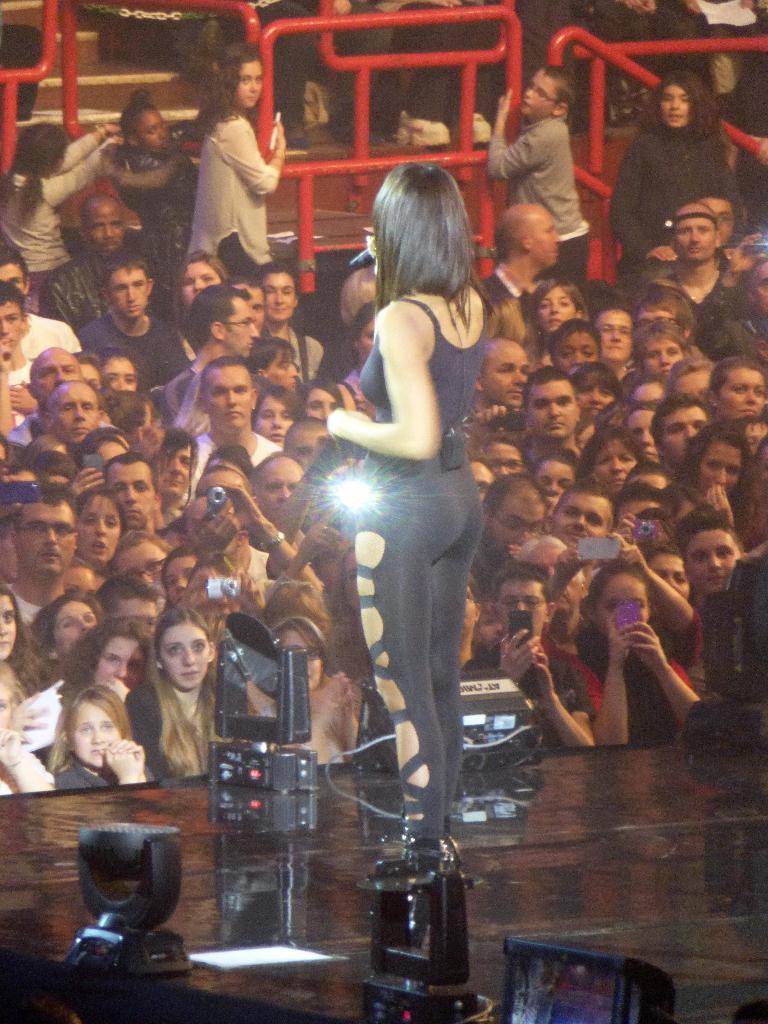Please provide a concise description of this image. In this picture , We can see spectators , Who are holding mobiles, cameras and there is a women, Who is holding a mike and we can see few lights after that i can see a floor, They are few women's, Who are holding an iron grill. 